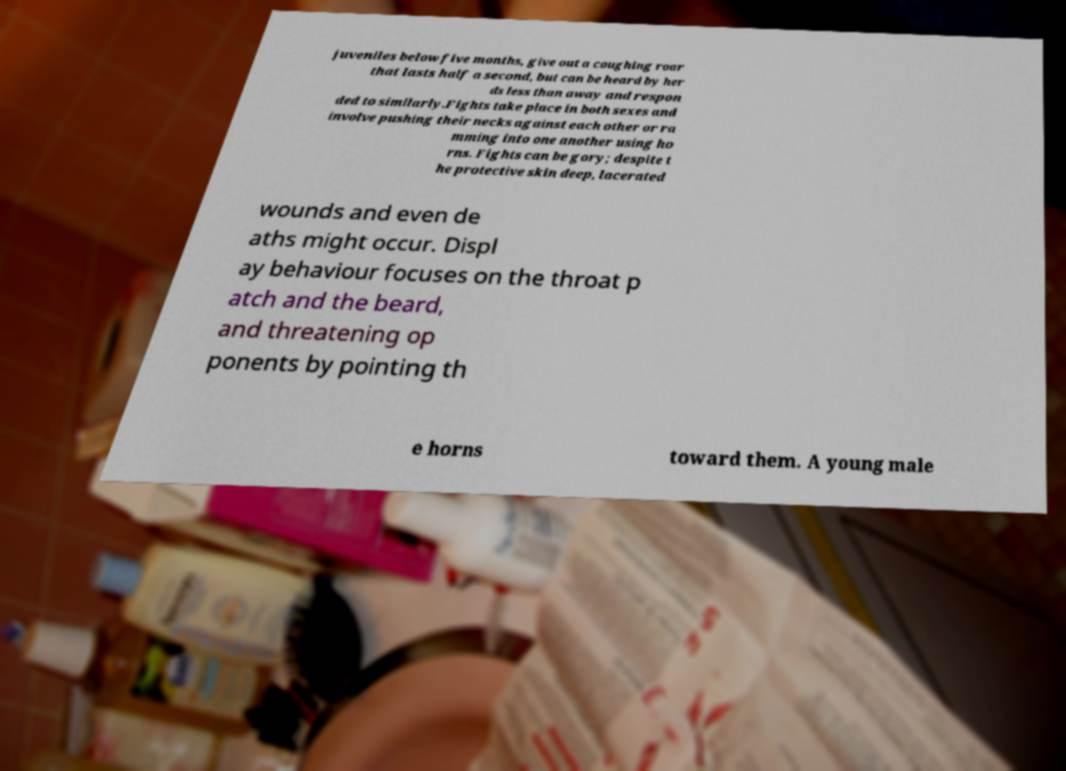There's text embedded in this image that I need extracted. Can you transcribe it verbatim? juveniles below five months, give out a coughing roar that lasts half a second, but can be heard by her ds less than away and respon ded to similarly.Fights take place in both sexes and involve pushing their necks against each other or ra mming into one another using ho rns. Fights can be gory; despite t he protective skin deep, lacerated wounds and even de aths might occur. Displ ay behaviour focuses on the throat p atch and the beard, and threatening op ponents by pointing th e horns toward them. A young male 